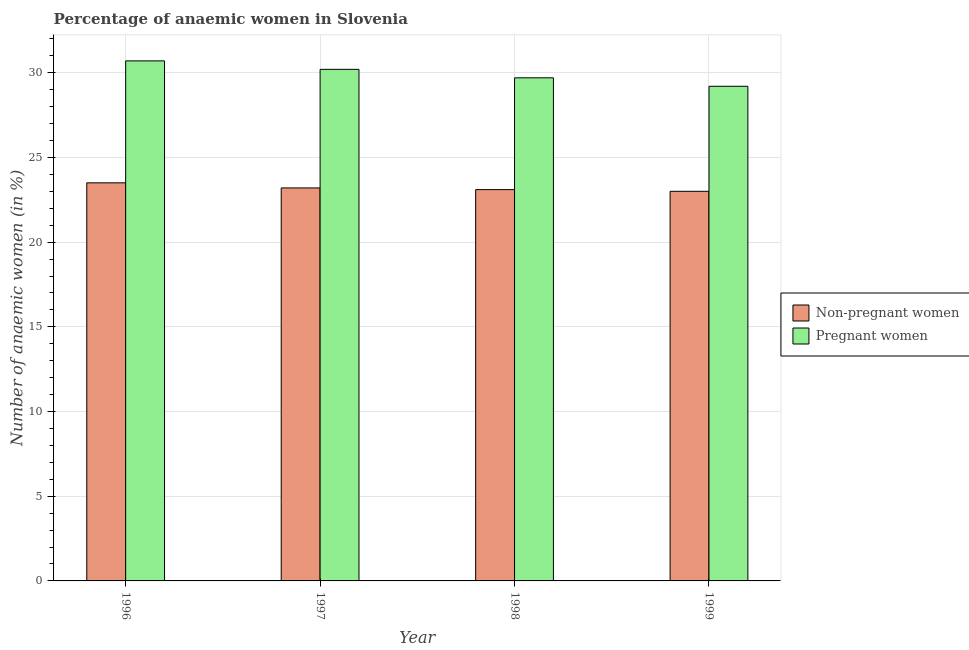How many different coloured bars are there?
Your response must be concise. 2. How many groups of bars are there?
Provide a succinct answer. 4. Are the number of bars per tick equal to the number of legend labels?
Offer a terse response. Yes. Are the number of bars on each tick of the X-axis equal?
Offer a very short reply. Yes. What is the label of the 2nd group of bars from the left?
Offer a terse response. 1997. In how many cases, is the number of bars for a given year not equal to the number of legend labels?
Offer a terse response. 0. What is the percentage of pregnant anaemic women in 1996?
Make the answer very short. 30.7. Across all years, what is the minimum percentage of pregnant anaemic women?
Your answer should be very brief. 29.2. What is the total percentage of pregnant anaemic women in the graph?
Give a very brief answer. 119.8. What is the difference between the percentage of non-pregnant anaemic women in 1997 and the percentage of pregnant anaemic women in 1999?
Provide a succinct answer. 0.2. What is the average percentage of non-pregnant anaemic women per year?
Offer a terse response. 23.2. What is the ratio of the percentage of non-pregnant anaemic women in 1996 to that in 1998?
Your answer should be very brief. 1.02. Is the percentage of pregnant anaemic women in 1998 less than that in 1999?
Provide a succinct answer. No. What is the difference between the highest and the second highest percentage of non-pregnant anaemic women?
Your answer should be very brief. 0.3. What is the difference between the highest and the lowest percentage of non-pregnant anaemic women?
Ensure brevity in your answer.  0.5. Is the sum of the percentage of non-pregnant anaemic women in 1996 and 1998 greater than the maximum percentage of pregnant anaemic women across all years?
Provide a succinct answer. Yes. What does the 1st bar from the left in 1999 represents?
Your answer should be very brief. Non-pregnant women. What does the 2nd bar from the right in 1999 represents?
Give a very brief answer. Non-pregnant women. How many bars are there?
Offer a terse response. 8. What is the difference between two consecutive major ticks on the Y-axis?
Your response must be concise. 5. Are the values on the major ticks of Y-axis written in scientific E-notation?
Give a very brief answer. No. Does the graph contain any zero values?
Give a very brief answer. No. Does the graph contain grids?
Ensure brevity in your answer.  Yes. Where does the legend appear in the graph?
Give a very brief answer. Center right. How many legend labels are there?
Make the answer very short. 2. What is the title of the graph?
Offer a very short reply. Percentage of anaemic women in Slovenia. Does "Registered firms" appear as one of the legend labels in the graph?
Provide a succinct answer. No. What is the label or title of the X-axis?
Provide a succinct answer. Year. What is the label or title of the Y-axis?
Your answer should be very brief. Number of anaemic women (in %). What is the Number of anaemic women (in %) of Pregnant women in 1996?
Give a very brief answer. 30.7. What is the Number of anaemic women (in %) in Non-pregnant women in 1997?
Your response must be concise. 23.2. What is the Number of anaemic women (in %) in Pregnant women in 1997?
Keep it short and to the point. 30.2. What is the Number of anaemic women (in %) of Non-pregnant women in 1998?
Your answer should be very brief. 23.1. What is the Number of anaemic women (in %) in Pregnant women in 1998?
Provide a short and direct response. 29.7. What is the Number of anaemic women (in %) of Pregnant women in 1999?
Provide a short and direct response. 29.2. Across all years, what is the maximum Number of anaemic women (in %) of Pregnant women?
Your answer should be very brief. 30.7. Across all years, what is the minimum Number of anaemic women (in %) of Non-pregnant women?
Keep it short and to the point. 23. Across all years, what is the minimum Number of anaemic women (in %) of Pregnant women?
Give a very brief answer. 29.2. What is the total Number of anaemic women (in %) in Non-pregnant women in the graph?
Your response must be concise. 92.8. What is the total Number of anaemic women (in %) of Pregnant women in the graph?
Offer a very short reply. 119.8. What is the difference between the Number of anaemic women (in %) of Non-pregnant women in 1996 and that in 1997?
Provide a succinct answer. 0.3. What is the difference between the Number of anaemic women (in %) in Pregnant women in 1996 and that in 1997?
Offer a terse response. 0.5. What is the difference between the Number of anaemic women (in %) in Non-pregnant women in 1996 and that in 1999?
Your response must be concise. 0.5. What is the difference between the Number of anaemic women (in %) in Pregnant women in 1996 and that in 1999?
Provide a short and direct response. 1.5. What is the difference between the Number of anaemic women (in %) in Pregnant women in 1997 and that in 1999?
Make the answer very short. 1. What is the difference between the Number of anaemic women (in %) of Non-pregnant women in 1998 and that in 1999?
Make the answer very short. 0.1. What is the difference between the Number of anaemic women (in %) in Pregnant women in 1998 and that in 1999?
Make the answer very short. 0.5. What is the difference between the Number of anaemic women (in %) in Non-pregnant women in 1996 and the Number of anaemic women (in %) in Pregnant women in 1998?
Make the answer very short. -6.2. What is the difference between the Number of anaemic women (in %) of Non-pregnant women in 1997 and the Number of anaemic women (in %) of Pregnant women in 1999?
Keep it short and to the point. -6. What is the difference between the Number of anaemic women (in %) in Non-pregnant women in 1998 and the Number of anaemic women (in %) in Pregnant women in 1999?
Provide a short and direct response. -6.1. What is the average Number of anaemic women (in %) in Non-pregnant women per year?
Ensure brevity in your answer.  23.2. What is the average Number of anaemic women (in %) of Pregnant women per year?
Make the answer very short. 29.95. In the year 1997, what is the difference between the Number of anaemic women (in %) in Non-pregnant women and Number of anaemic women (in %) in Pregnant women?
Keep it short and to the point. -7. In the year 1998, what is the difference between the Number of anaemic women (in %) in Non-pregnant women and Number of anaemic women (in %) in Pregnant women?
Ensure brevity in your answer.  -6.6. What is the ratio of the Number of anaemic women (in %) of Non-pregnant women in 1996 to that in 1997?
Give a very brief answer. 1.01. What is the ratio of the Number of anaemic women (in %) of Pregnant women in 1996 to that in 1997?
Provide a short and direct response. 1.02. What is the ratio of the Number of anaemic women (in %) in Non-pregnant women in 1996 to that in 1998?
Offer a terse response. 1.02. What is the ratio of the Number of anaemic women (in %) in Pregnant women in 1996 to that in 1998?
Provide a succinct answer. 1.03. What is the ratio of the Number of anaemic women (in %) of Non-pregnant women in 1996 to that in 1999?
Give a very brief answer. 1.02. What is the ratio of the Number of anaemic women (in %) of Pregnant women in 1996 to that in 1999?
Offer a terse response. 1.05. What is the ratio of the Number of anaemic women (in %) of Non-pregnant women in 1997 to that in 1998?
Your response must be concise. 1. What is the ratio of the Number of anaemic women (in %) of Pregnant women in 1997 to that in 1998?
Offer a terse response. 1.02. What is the ratio of the Number of anaemic women (in %) in Non-pregnant women in 1997 to that in 1999?
Your answer should be very brief. 1.01. What is the ratio of the Number of anaemic women (in %) in Pregnant women in 1997 to that in 1999?
Offer a terse response. 1.03. What is the ratio of the Number of anaemic women (in %) of Non-pregnant women in 1998 to that in 1999?
Ensure brevity in your answer.  1. What is the ratio of the Number of anaemic women (in %) in Pregnant women in 1998 to that in 1999?
Give a very brief answer. 1.02. What is the difference between the highest and the second highest Number of anaemic women (in %) in Non-pregnant women?
Your response must be concise. 0.3. What is the difference between the highest and the lowest Number of anaemic women (in %) in Non-pregnant women?
Provide a short and direct response. 0.5. What is the difference between the highest and the lowest Number of anaemic women (in %) in Pregnant women?
Provide a succinct answer. 1.5. 